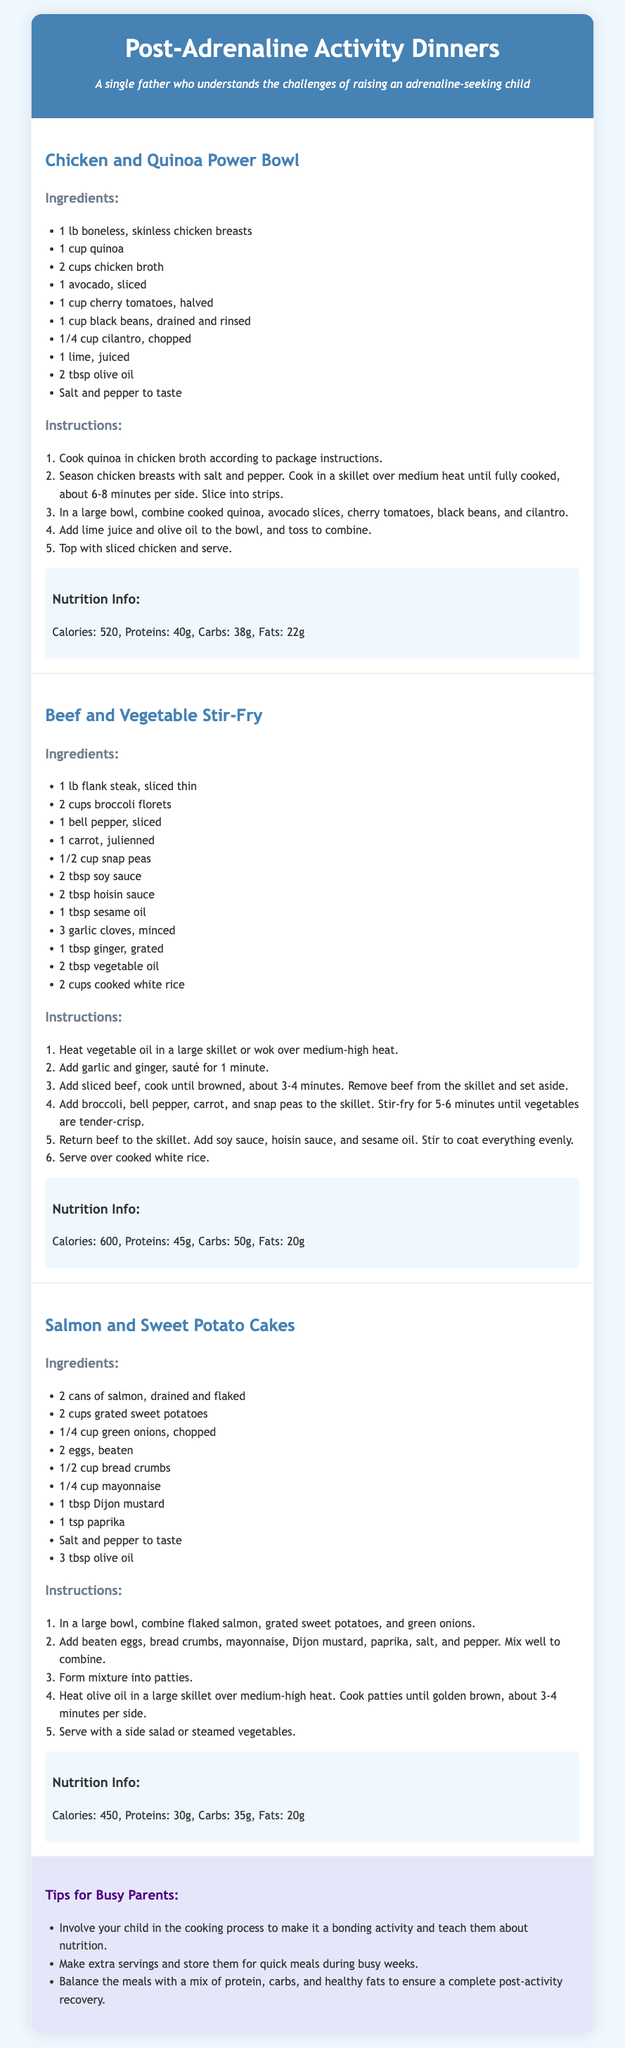what is the first recipe in the document? The first recipe listed in the document is "Chicken and Quinoa Power Bowl."
Answer: Chicken and Quinoa Power Bowl how many calories are in the Beef and Vegetable Stir-Fry? The nutrition info for Beef and Vegetable Stir-Fry states that it contains 600 calories.
Answer: 600 what ingredient is used to season the chicken in the Chicken and Quinoa Power Bowl? The recipe specifies that the chicken breasts are seasoned with salt and pepper.
Answer: salt and pepper how many cups of broccoli florets are needed for the Beef and Vegetable Stir-Fry? The ingredients section lists 2 cups of broccoli florets as needed for this recipe.
Answer: 2 cups what are the total proteins in the Salmon and Sweet Potato Cakes? The nutrition info indicates that Salmon and Sweet Potato Cakes contain 30g of proteins.
Answer: 30g which oil is mentioned as an ingredient in the Beef and Vegetable Stir-Fry? The ingredients list includes sesame oil for the Beef and Vegetable Stir-Fry.
Answer: sesame oil how many eggs are needed for the Salmon and Sweet Potato Cakes? The recipe requires 2 eggs, as stated in the ingredients section.
Answer: 2 eggs what is one tip for busy parents provided in the document? One of the tips suggests that parents involve their child in the cooking process.
Answer: involve your child in the cooking process what is the cooking time for the chicken breasts in the Chicken and Quinoa Power Bowl? The instructions indicate that the chicken should be cooked for about 6-8 minutes per side.
Answer: 6-8 minutes per side 